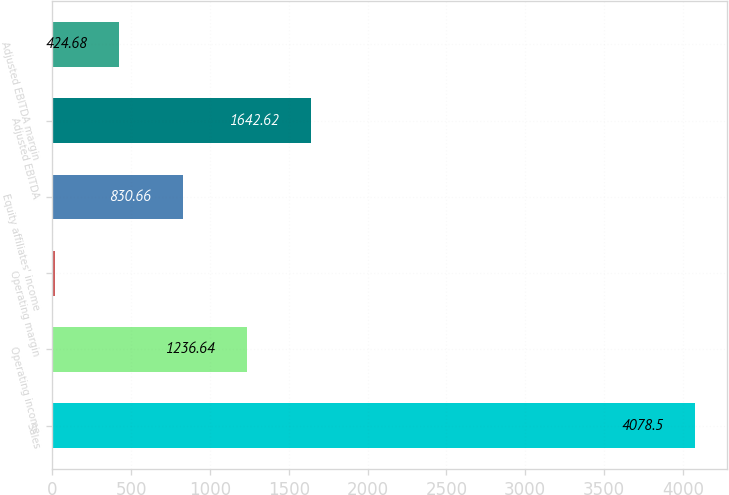Convert chart to OTSL. <chart><loc_0><loc_0><loc_500><loc_500><bar_chart><fcel>Sales<fcel>Operating income<fcel>Operating margin<fcel>Equity affiliates' income<fcel>Adjusted EBITDA<fcel>Adjusted EBITDA margin<nl><fcel>4078.5<fcel>1236.64<fcel>18.7<fcel>830.66<fcel>1642.62<fcel>424.68<nl></chart> 